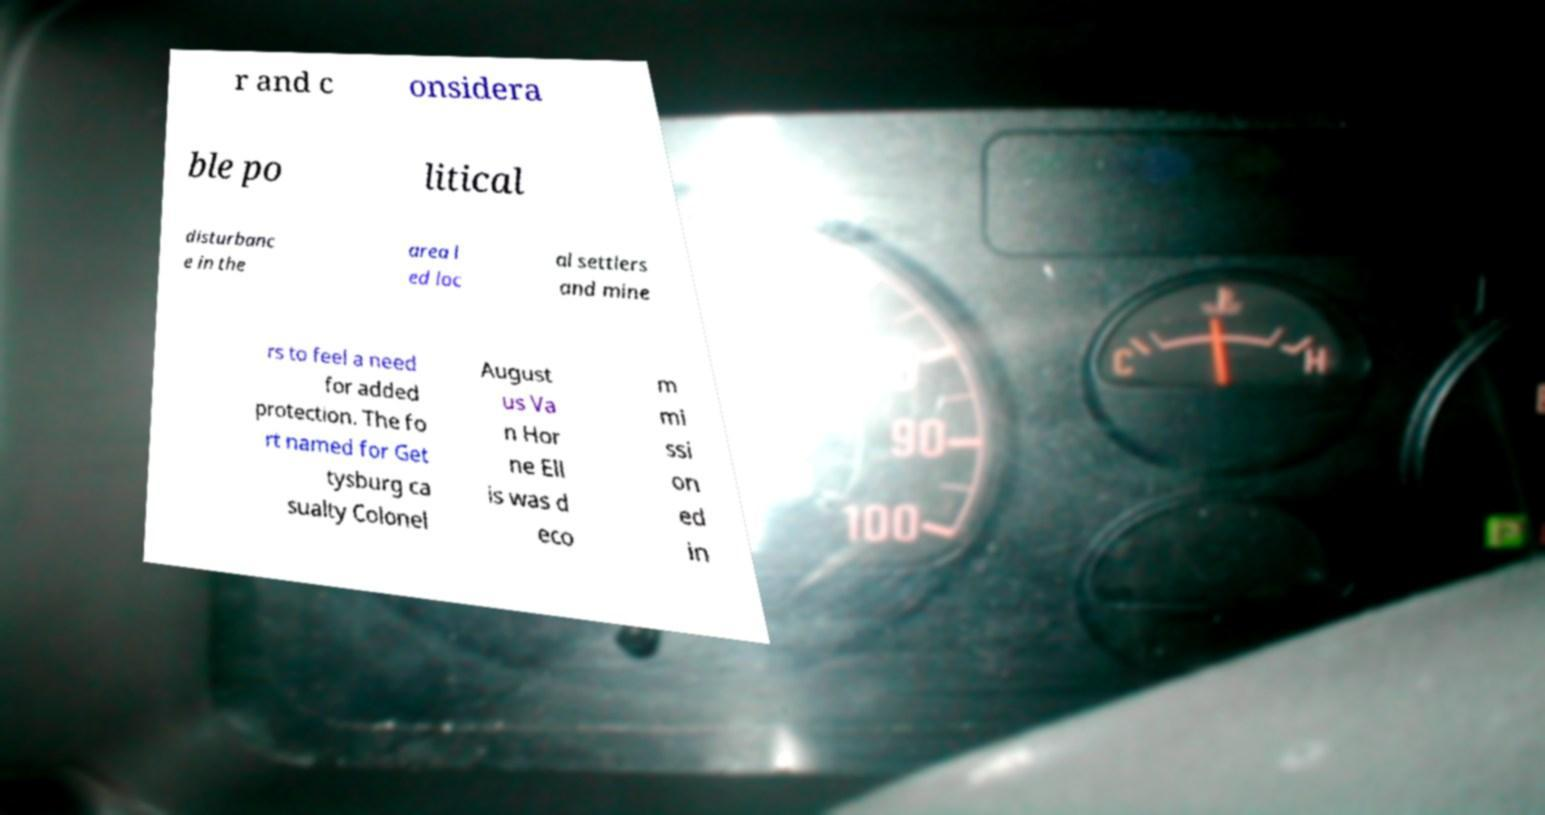Could you extract and type out the text from this image? r and c onsidera ble po litical disturbanc e in the area l ed loc al settlers and mine rs to feel a need for added protection. The fo rt named for Get tysburg ca sualty Colonel August us Va n Hor ne Ell is was d eco m mi ssi on ed in 